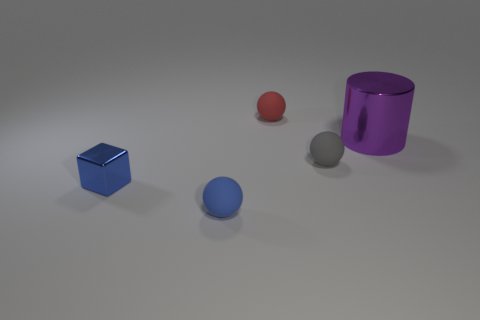Add 1 purple cylinders. How many objects exist? 6 Subtract all cylinders. How many objects are left? 4 Subtract all blue spheres. How many spheres are left? 2 Subtract all yellow cylinders. Subtract all red balls. How many cylinders are left? 1 Subtract all yellow spheres. How many red cubes are left? 0 Subtract all brown things. Subtract all small blue balls. How many objects are left? 4 Add 4 blue rubber spheres. How many blue rubber spheres are left? 5 Add 2 big red cylinders. How many big red cylinders exist? 2 Subtract 1 red spheres. How many objects are left? 4 